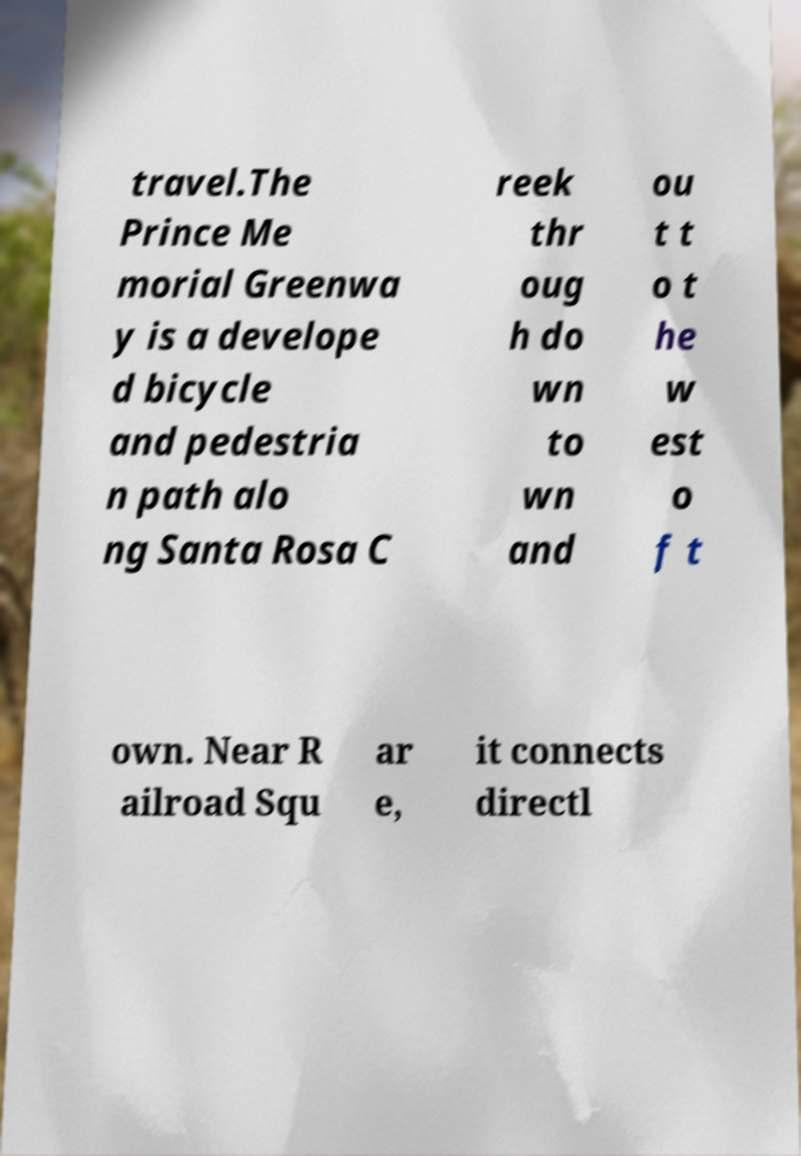Can you accurately transcribe the text from the provided image for me? travel.The Prince Me morial Greenwa y is a develope d bicycle and pedestria n path alo ng Santa Rosa C reek thr oug h do wn to wn and ou t t o t he w est o f t own. Near R ailroad Squ ar e, it connects directl 